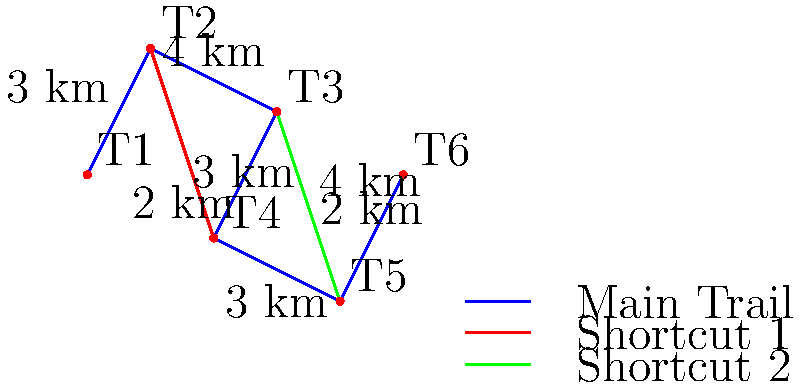Based on the simplified trail map of the hiking network around Kladanj, what is the shortest distance a hiker needs to travel from Trail Point 1 (T1) to Trail Point 6 (T6)? To find the shortest distance from T1 to T6, we need to consider all possible routes:

1. Main trail only: T1 -> T2 -> T3 -> T4 -> T5 -> T6
   Distance = 3 + 4 + 2 + 3 + 2 = 14 km

2. Using Shortcut 1: T1 -> T2 -> T4 -> T5 -> T6
   Distance = 3 + 3 + 3 + 2 = 11 km

3. Using Shortcut 2: T1 -> T2 -> T3 -> T5 -> T6
   Distance = 3 + 4 + 4 + 2 = 13 km

4. Using both shortcuts: T1 -> T2 -> T4 -> T5 -> T6
   This is the same as option 2.

The shortest route is option 2, using Shortcut 1:
T1 -> T2 -> T4 -> T5 -> T6, with a total distance of 11 km.
Answer: 11 km 